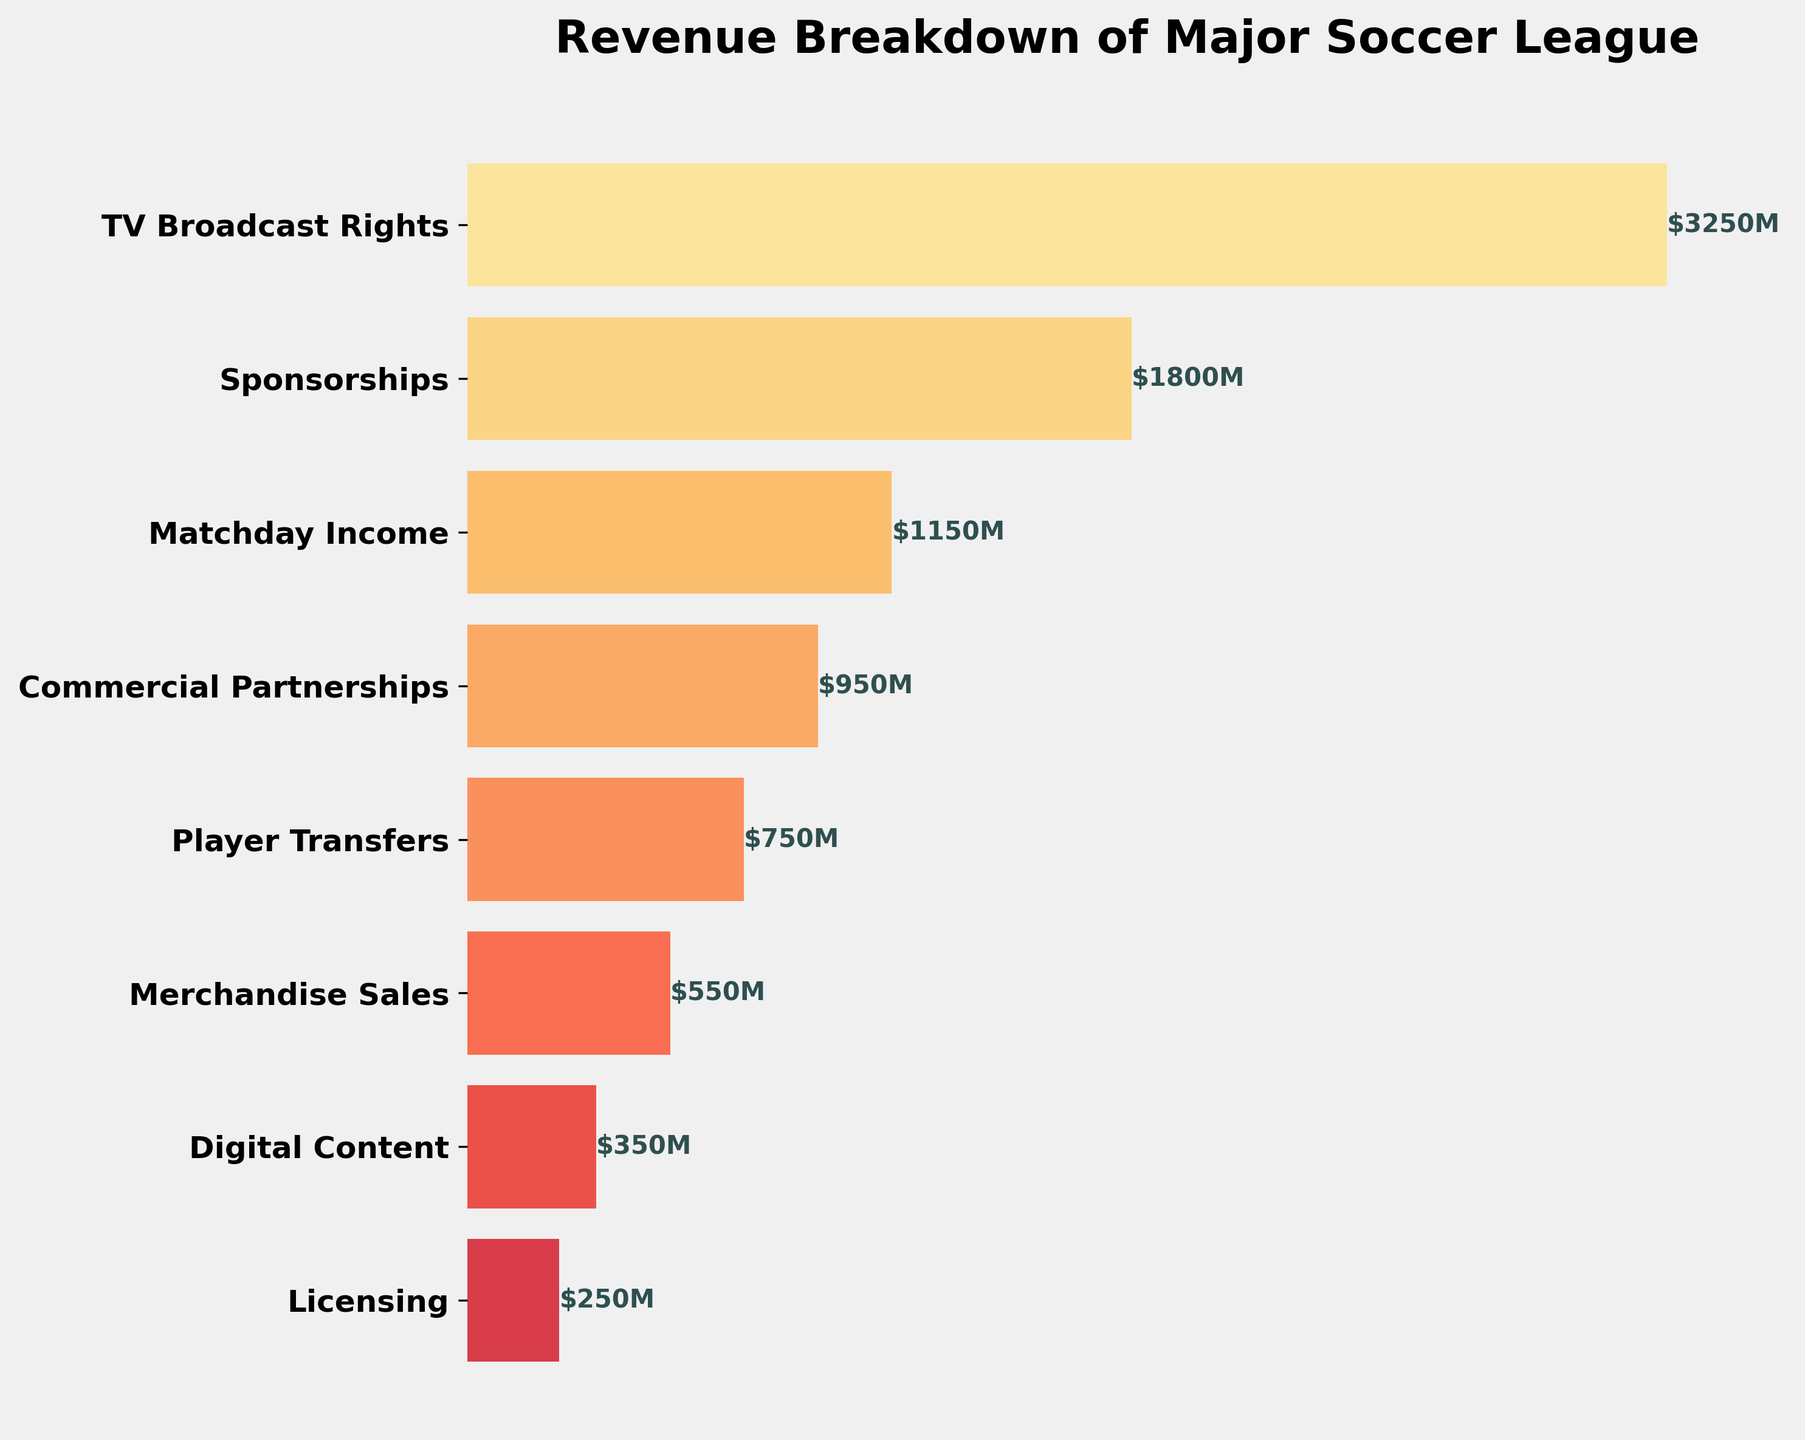What is the title of the figure? The title is usually located at the top of the figure, displaying the main idea or topic of the plot. Here, the title reads "Revenue Breakdown of Major Soccer League".
Answer: Revenue Breakdown of Major Soccer League What revenue category has the highest value? By observing the bars in the funnel chart, the longest bar represents the highest revenue category. The category corresponding to the longest bar is "TV Broadcast Rights".
Answer: TV Broadcast Rights Which revenue category has the lowest value? The shortest bar in the funnel chart corresponds to the lowest revenue category. The category next to the shortest bar is "Licensing".
Answer: Licensing How much revenue does Matchday Income generate? Next to the "Matchday Income" bar, the revenue value is displayed. It shows $1150M.
Answer: $1150M What is the total revenue generated by Player Transfers and Merchandise Sales combined? The figure shows $750M for Player Transfers and $550M for Merchandise Sales. Adding these two values gives $750M + $550M = $1300M.
Answer: $1300M Which category generates more revenue: Sponsorships or Commercial Partnerships? By comparing the lengths of the bars and their corresponding values, "Sponsorships" generates $1800M while "Commercial Partnerships" generates $950M. Since $1800M is greater than $950M, Sponsorships generate more revenue.
Answer: Sponsorships What is the cumulative revenue from Digital Content, Licensing, and Player Transfers? The revenue values for Digital Content, Licensing, and Player Transfers are $350M, $250M, and $750M, respectively. Summing these values: $350M + $250M + $750M = $1350M.
Answer: $1350M Which categories have revenue figures over $1000M? The categories with revenue figures over $1000M, as identified by checking the values next to the bars, are "TV Broadcast Rights", "Sponsorships", and "Matchday Income".
Answer: TV Broadcast Rights, Sponsorships, Matchday Income How much more revenue does TV Broadcast Rights generate compared to Digital Content? TV Broadcast Rights generate $3250M, and Digital Content generates $350M. Subtracting these values: $3250M - $350M = $2900M.
Answer: $2900M 